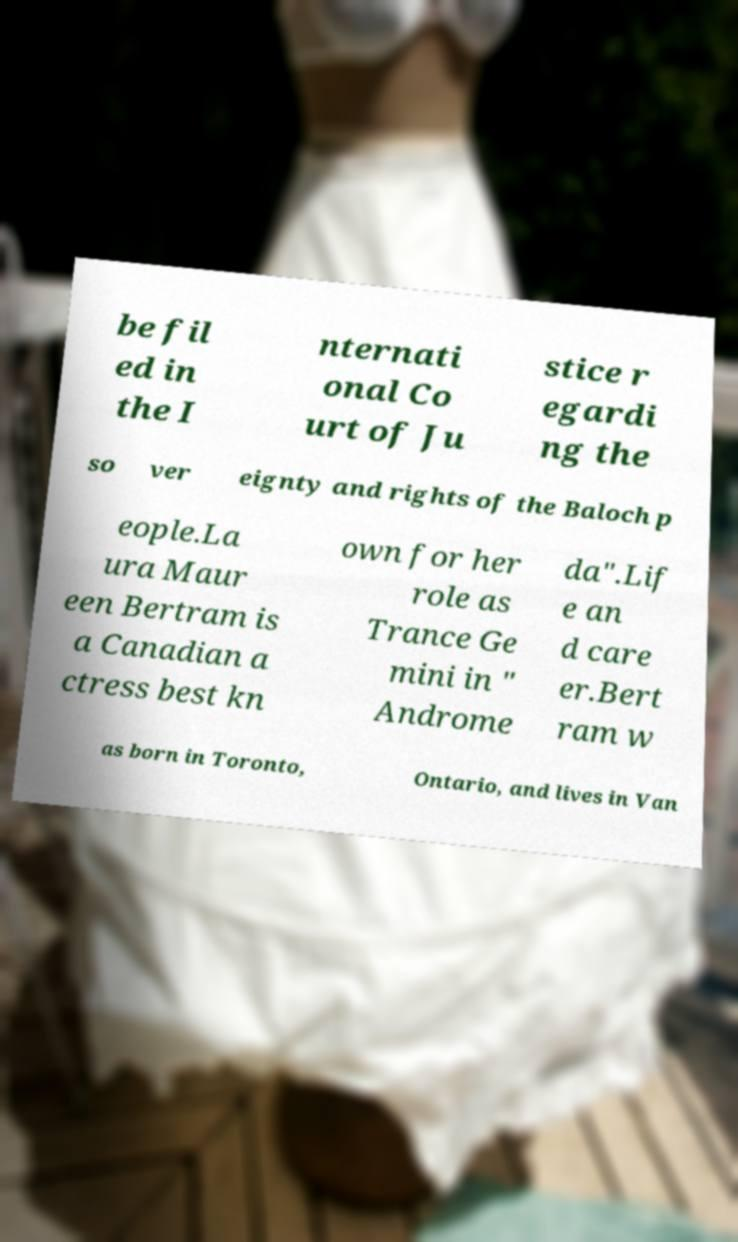I need the written content from this picture converted into text. Can you do that? be fil ed in the I nternati onal Co urt of Ju stice r egardi ng the so ver eignty and rights of the Baloch p eople.La ura Maur een Bertram is a Canadian a ctress best kn own for her role as Trance Ge mini in " Androme da".Lif e an d care er.Bert ram w as born in Toronto, Ontario, and lives in Van 